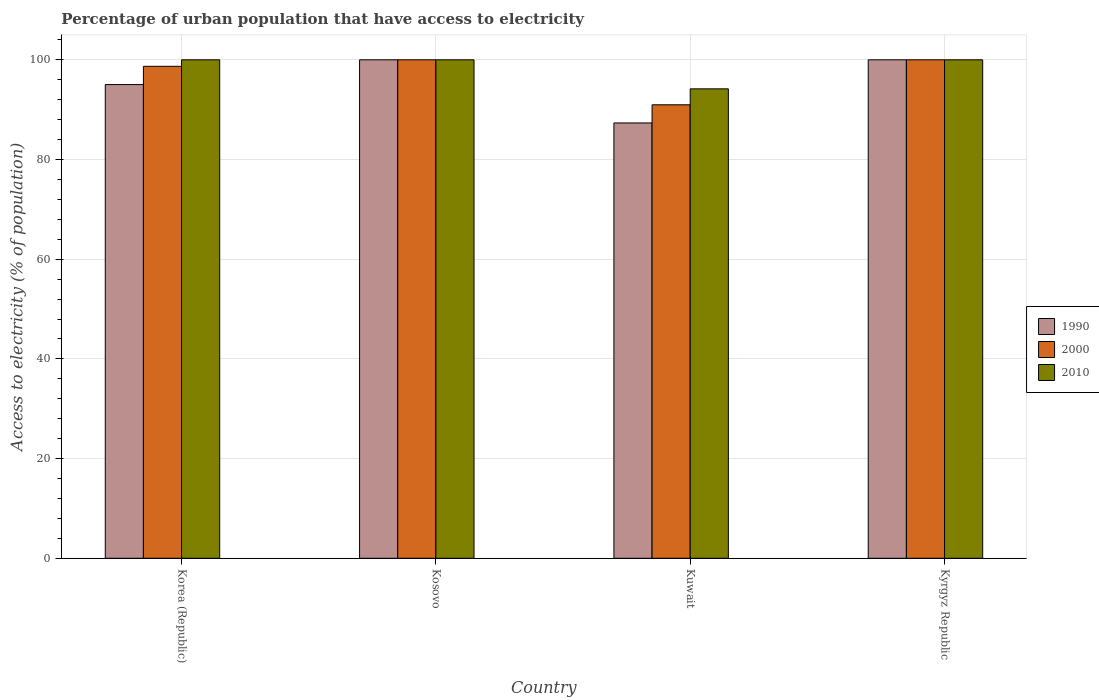How many different coloured bars are there?
Provide a succinct answer. 3. Are the number of bars per tick equal to the number of legend labels?
Provide a short and direct response. Yes. How many bars are there on the 2nd tick from the left?
Keep it short and to the point. 3. How many bars are there on the 2nd tick from the right?
Offer a very short reply. 3. In how many cases, is the number of bars for a given country not equal to the number of legend labels?
Give a very brief answer. 0. What is the percentage of urban population that have access to electricity in 2000 in Kyrgyz Republic?
Your answer should be compact. 100. Across all countries, what is the minimum percentage of urban population that have access to electricity in 2000?
Your answer should be very brief. 90.98. In which country was the percentage of urban population that have access to electricity in 2010 minimum?
Offer a terse response. Kuwait. What is the total percentage of urban population that have access to electricity in 1990 in the graph?
Offer a terse response. 382.36. What is the difference between the percentage of urban population that have access to electricity in 2000 in Korea (Republic) and that in Kosovo?
Ensure brevity in your answer.  -1.31. What is the difference between the percentage of urban population that have access to electricity in 1990 in Kuwait and the percentage of urban population that have access to electricity in 2000 in Kosovo?
Your answer should be very brief. -12.67. What is the average percentage of urban population that have access to electricity in 1990 per country?
Give a very brief answer. 95.59. What is the difference between the percentage of urban population that have access to electricity of/in 2010 and percentage of urban population that have access to electricity of/in 1990 in Kuwait?
Ensure brevity in your answer.  6.84. In how many countries, is the percentage of urban population that have access to electricity in 1990 greater than 92 %?
Offer a very short reply. 3. Is the difference between the percentage of urban population that have access to electricity in 2010 in Kuwait and Kyrgyz Republic greater than the difference between the percentage of urban population that have access to electricity in 1990 in Kuwait and Kyrgyz Republic?
Your response must be concise. Yes. What is the difference between the highest and the second highest percentage of urban population that have access to electricity in 1990?
Ensure brevity in your answer.  4.97. What is the difference between the highest and the lowest percentage of urban population that have access to electricity in 2010?
Your response must be concise. 5.83. Is the sum of the percentage of urban population that have access to electricity in 2000 in Korea (Republic) and Kosovo greater than the maximum percentage of urban population that have access to electricity in 1990 across all countries?
Your answer should be compact. Yes. What does the 2nd bar from the left in Korea (Republic) represents?
Provide a short and direct response. 2000. What does the 2nd bar from the right in Kuwait represents?
Offer a very short reply. 2000. Are all the bars in the graph horizontal?
Offer a very short reply. No. Does the graph contain any zero values?
Your response must be concise. No. Where does the legend appear in the graph?
Make the answer very short. Center right. How are the legend labels stacked?
Your response must be concise. Vertical. What is the title of the graph?
Keep it short and to the point. Percentage of urban population that have access to electricity. What is the label or title of the Y-axis?
Keep it short and to the point. Access to electricity (% of population). What is the Access to electricity (% of population) of 1990 in Korea (Republic)?
Give a very brief answer. 95.03. What is the Access to electricity (% of population) of 2000 in Korea (Republic)?
Your answer should be very brief. 98.69. What is the Access to electricity (% of population) in 1990 in Kosovo?
Give a very brief answer. 100. What is the Access to electricity (% of population) of 2000 in Kosovo?
Offer a very short reply. 100. What is the Access to electricity (% of population) in 1990 in Kuwait?
Offer a very short reply. 87.33. What is the Access to electricity (% of population) of 2000 in Kuwait?
Offer a terse response. 90.98. What is the Access to electricity (% of population) in 2010 in Kuwait?
Your answer should be compact. 94.17. What is the Access to electricity (% of population) in 1990 in Kyrgyz Republic?
Your response must be concise. 100. Across all countries, what is the maximum Access to electricity (% of population) of 1990?
Ensure brevity in your answer.  100. Across all countries, what is the maximum Access to electricity (% of population) of 2000?
Offer a terse response. 100. Across all countries, what is the maximum Access to electricity (% of population) in 2010?
Your answer should be compact. 100. Across all countries, what is the minimum Access to electricity (% of population) in 1990?
Offer a terse response. 87.33. Across all countries, what is the minimum Access to electricity (% of population) of 2000?
Your answer should be compact. 90.98. Across all countries, what is the minimum Access to electricity (% of population) of 2010?
Give a very brief answer. 94.17. What is the total Access to electricity (% of population) in 1990 in the graph?
Keep it short and to the point. 382.36. What is the total Access to electricity (% of population) of 2000 in the graph?
Provide a short and direct response. 389.67. What is the total Access to electricity (% of population) of 2010 in the graph?
Offer a terse response. 394.17. What is the difference between the Access to electricity (% of population) of 1990 in Korea (Republic) and that in Kosovo?
Ensure brevity in your answer.  -4.97. What is the difference between the Access to electricity (% of population) in 2000 in Korea (Republic) and that in Kosovo?
Make the answer very short. -1.31. What is the difference between the Access to electricity (% of population) of 1990 in Korea (Republic) and that in Kuwait?
Ensure brevity in your answer.  7.7. What is the difference between the Access to electricity (% of population) of 2000 in Korea (Republic) and that in Kuwait?
Provide a short and direct response. 7.72. What is the difference between the Access to electricity (% of population) of 2010 in Korea (Republic) and that in Kuwait?
Give a very brief answer. 5.83. What is the difference between the Access to electricity (% of population) of 1990 in Korea (Republic) and that in Kyrgyz Republic?
Offer a very short reply. -4.97. What is the difference between the Access to electricity (% of population) of 2000 in Korea (Republic) and that in Kyrgyz Republic?
Offer a very short reply. -1.31. What is the difference between the Access to electricity (% of population) of 1990 in Kosovo and that in Kuwait?
Your answer should be very brief. 12.67. What is the difference between the Access to electricity (% of population) of 2000 in Kosovo and that in Kuwait?
Keep it short and to the point. 9.02. What is the difference between the Access to electricity (% of population) in 2010 in Kosovo and that in Kuwait?
Your answer should be very brief. 5.83. What is the difference between the Access to electricity (% of population) of 2000 in Kosovo and that in Kyrgyz Republic?
Your response must be concise. 0. What is the difference between the Access to electricity (% of population) in 2010 in Kosovo and that in Kyrgyz Republic?
Offer a very short reply. 0. What is the difference between the Access to electricity (% of population) of 1990 in Kuwait and that in Kyrgyz Republic?
Your answer should be very brief. -12.67. What is the difference between the Access to electricity (% of population) in 2000 in Kuwait and that in Kyrgyz Republic?
Offer a terse response. -9.02. What is the difference between the Access to electricity (% of population) in 2010 in Kuwait and that in Kyrgyz Republic?
Keep it short and to the point. -5.83. What is the difference between the Access to electricity (% of population) of 1990 in Korea (Republic) and the Access to electricity (% of population) of 2000 in Kosovo?
Provide a succinct answer. -4.97. What is the difference between the Access to electricity (% of population) in 1990 in Korea (Republic) and the Access to electricity (% of population) in 2010 in Kosovo?
Provide a succinct answer. -4.97. What is the difference between the Access to electricity (% of population) of 2000 in Korea (Republic) and the Access to electricity (% of population) of 2010 in Kosovo?
Offer a very short reply. -1.31. What is the difference between the Access to electricity (% of population) of 1990 in Korea (Republic) and the Access to electricity (% of population) of 2000 in Kuwait?
Keep it short and to the point. 4.05. What is the difference between the Access to electricity (% of population) of 1990 in Korea (Republic) and the Access to electricity (% of population) of 2010 in Kuwait?
Keep it short and to the point. 0.86. What is the difference between the Access to electricity (% of population) in 2000 in Korea (Republic) and the Access to electricity (% of population) in 2010 in Kuwait?
Ensure brevity in your answer.  4.52. What is the difference between the Access to electricity (% of population) of 1990 in Korea (Republic) and the Access to electricity (% of population) of 2000 in Kyrgyz Republic?
Make the answer very short. -4.97. What is the difference between the Access to electricity (% of population) of 1990 in Korea (Republic) and the Access to electricity (% of population) of 2010 in Kyrgyz Republic?
Provide a short and direct response. -4.97. What is the difference between the Access to electricity (% of population) in 2000 in Korea (Republic) and the Access to electricity (% of population) in 2010 in Kyrgyz Republic?
Make the answer very short. -1.31. What is the difference between the Access to electricity (% of population) in 1990 in Kosovo and the Access to electricity (% of population) in 2000 in Kuwait?
Keep it short and to the point. 9.02. What is the difference between the Access to electricity (% of population) in 1990 in Kosovo and the Access to electricity (% of population) in 2010 in Kuwait?
Keep it short and to the point. 5.83. What is the difference between the Access to electricity (% of population) of 2000 in Kosovo and the Access to electricity (% of population) of 2010 in Kuwait?
Provide a succinct answer. 5.83. What is the difference between the Access to electricity (% of population) of 1990 in Kosovo and the Access to electricity (% of population) of 2010 in Kyrgyz Republic?
Provide a succinct answer. 0. What is the difference between the Access to electricity (% of population) of 2000 in Kosovo and the Access to electricity (% of population) of 2010 in Kyrgyz Republic?
Your answer should be very brief. 0. What is the difference between the Access to electricity (% of population) of 1990 in Kuwait and the Access to electricity (% of population) of 2000 in Kyrgyz Republic?
Give a very brief answer. -12.67. What is the difference between the Access to electricity (% of population) of 1990 in Kuwait and the Access to electricity (% of population) of 2010 in Kyrgyz Republic?
Offer a very short reply. -12.67. What is the difference between the Access to electricity (% of population) in 2000 in Kuwait and the Access to electricity (% of population) in 2010 in Kyrgyz Republic?
Keep it short and to the point. -9.02. What is the average Access to electricity (% of population) of 1990 per country?
Ensure brevity in your answer.  95.59. What is the average Access to electricity (% of population) in 2000 per country?
Give a very brief answer. 97.42. What is the average Access to electricity (% of population) of 2010 per country?
Make the answer very short. 98.54. What is the difference between the Access to electricity (% of population) in 1990 and Access to electricity (% of population) in 2000 in Korea (Republic)?
Offer a terse response. -3.66. What is the difference between the Access to electricity (% of population) in 1990 and Access to electricity (% of population) in 2010 in Korea (Republic)?
Provide a succinct answer. -4.97. What is the difference between the Access to electricity (% of population) in 2000 and Access to electricity (% of population) in 2010 in Korea (Republic)?
Offer a terse response. -1.31. What is the difference between the Access to electricity (% of population) in 1990 and Access to electricity (% of population) in 2000 in Kosovo?
Your response must be concise. 0. What is the difference between the Access to electricity (% of population) in 1990 and Access to electricity (% of population) in 2010 in Kosovo?
Offer a terse response. 0. What is the difference between the Access to electricity (% of population) in 2000 and Access to electricity (% of population) in 2010 in Kosovo?
Your answer should be compact. 0. What is the difference between the Access to electricity (% of population) in 1990 and Access to electricity (% of population) in 2000 in Kuwait?
Your response must be concise. -3.64. What is the difference between the Access to electricity (% of population) in 1990 and Access to electricity (% of population) in 2010 in Kuwait?
Give a very brief answer. -6.84. What is the difference between the Access to electricity (% of population) in 2000 and Access to electricity (% of population) in 2010 in Kuwait?
Your response must be concise. -3.2. What is the difference between the Access to electricity (% of population) of 1990 and Access to electricity (% of population) of 2000 in Kyrgyz Republic?
Offer a very short reply. 0. What is the difference between the Access to electricity (% of population) in 1990 and Access to electricity (% of population) in 2010 in Kyrgyz Republic?
Provide a succinct answer. 0. What is the ratio of the Access to electricity (% of population) in 1990 in Korea (Republic) to that in Kosovo?
Your answer should be very brief. 0.95. What is the ratio of the Access to electricity (% of population) in 2000 in Korea (Republic) to that in Kosovo?
Your answer should be very brief. 0.99. What is the ratio of the Access to electricity (% of population) of 2010 in Korea (Republic) to that in Kosovo?
Give a very brief answer. 1. What is the ratio of the Access to electricity (% of population) in 1990 in Korea (Republic) to that in Kuwait?
Make the answer very short. 1.09. What is the ratio of the Access to electricity (% of population) of 2000 in Korea (Republic) to that in Kuwait?
Your response must be concise. 1.08. What is the ratio of the Access to electricity (% of population) in 2010 in Korea (Republic) to that in Kuwait?
Your answer should be compact. 1.06. What is the ratio of the Access to electricity (% of population) in 1990 in Korea (Republic) to that in Kyrgyz Republic?
Offer a very short reply. 0.95. What is the ratio of the Access to electricity (% of population) in 2000 in Korea (Republic) to that in Kyrgyz Republic?
Give a very brief answer. 0.99. What is the ratio of the Access to electricity (% of population) in 1990 in Kosovo to that in Kuwait?
Offer a terse response. 1.15. What is the ratio of the Access to electricity (% of population) in 2000 in Kosovo to that in Kuwait?
Provide a short and direct response. 1.1. What is the ratio of the Access to electricity (% of population) in 2010 in Kosovo to that in Kuwait?
Offer a very short reply. 1.06. What is the ratio of the Access to electricity (% of population) in 1990 in Kosovo to that in Kyrgyz Republic?
Ensure brevity in your answer.  1. What is the ratio of the Access to electricity (% of population) in 2000 in Kosovo to that in Kyrgyz Republic?
Your answer should be very brief. 1. What is the ratio of the Access to electricity (% of population) of 1990 in Kuwait to that in Kyrgyz Republic?
Your answer should be very brief. 0.87. What is the ratio of the Access to electricity (% of population) in 2000 in Kuwait to that in Kyrgyz Republic?
Your answer should be very brief. 0.91. What is the ratio of the Access to electricity (% of population) of 2010 in Kuwait to that in Kyrgyz Republic?
Give a very brief answer. 0.94. What is the difference between the highest and the second highest Access to electricity (% of population) in 1990?
Make the answer very short. 0. What is the difference between the highest and the second highest Access to electricity (% of population) in 2000?
Your answer should be compact. 0. What is the difference between the highest and the lowest Access to electricity (% of population) in 1990?
Offer a terse response. 12.67. What is the difference between the highest and the lowest Access to electricity (% of population) in 2000?
Offer a very short reply. 9.02. What is the difference between the highest and the lowest Access to electricity (% of population) of 2010?
Offer a very short reply. 5.83. 